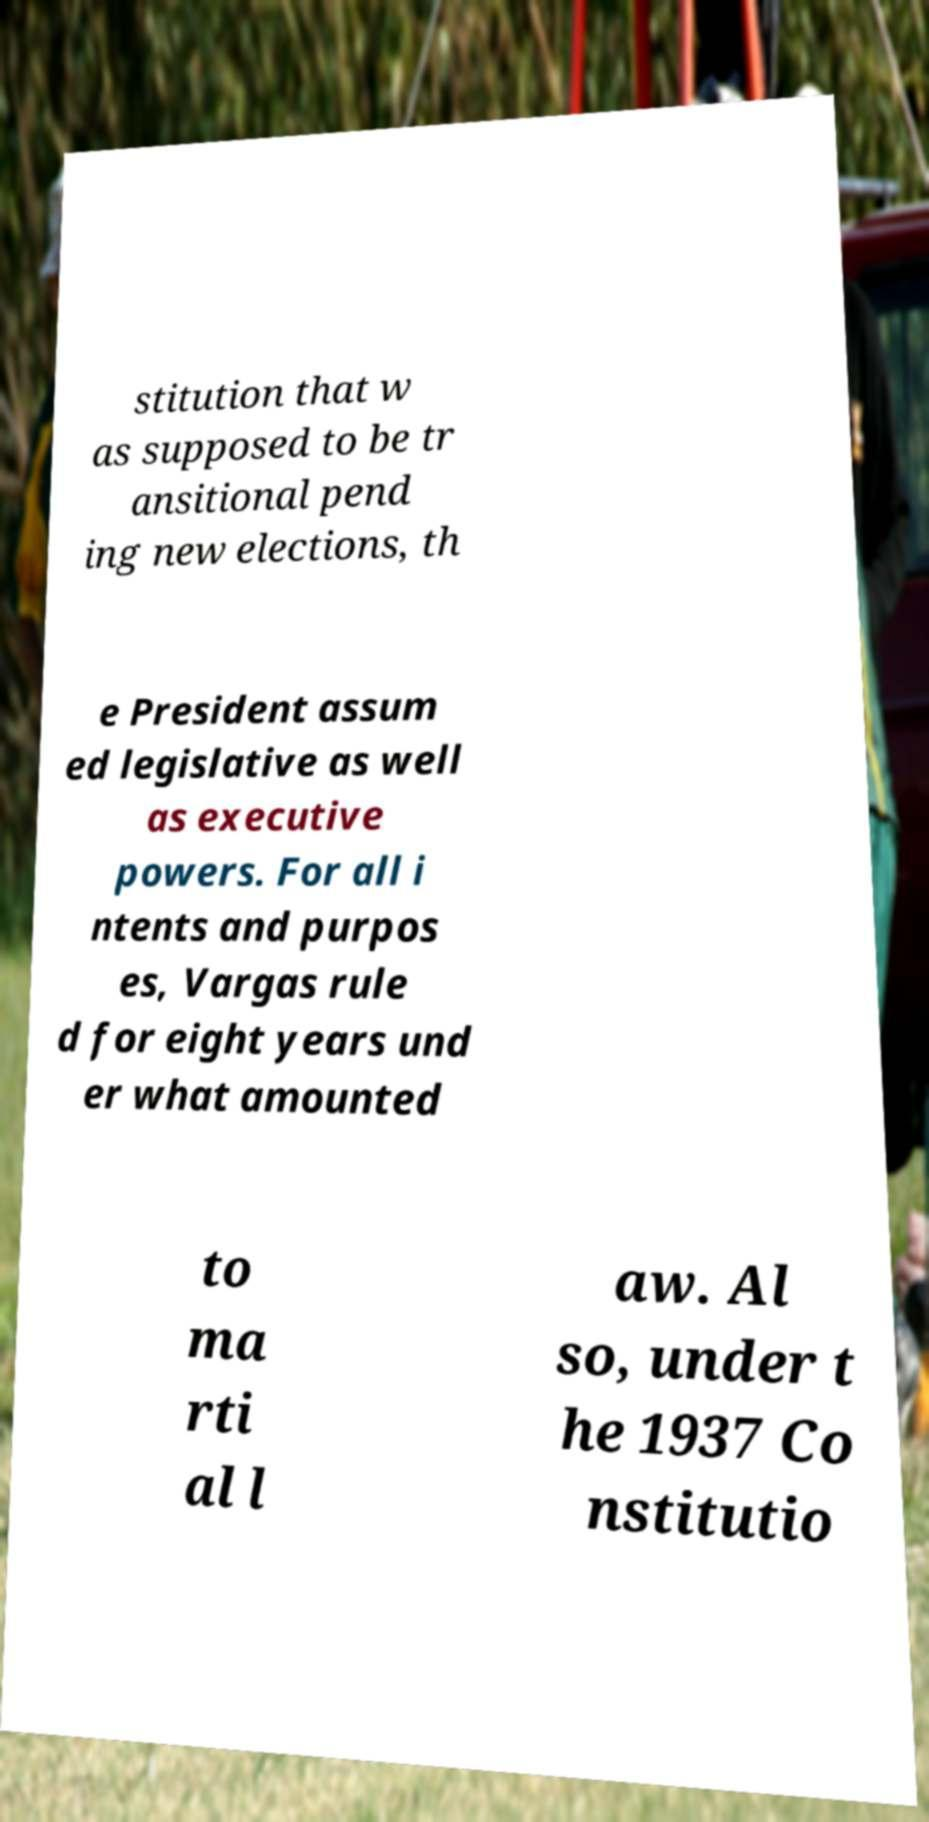Could you assist in decoding the text presented in this image and type it out clearly? stitution that w as supposed to be tr ansitional pend ing new elections, th e President assum ed legislative as well as executive powers. For all i ntents and purpos es, Vargas rule d for eight years und er what amounted to ma rti al l aw. Al so, under t he 1937 Co nstitutio 